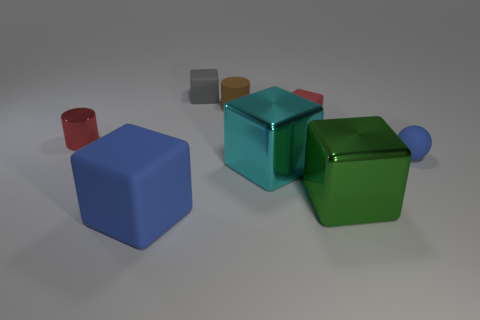Add 2 spheres. How many objects exist? 10 Subtract all yellow blocks. Subtract all yellow spheres. How many blocks are left? 5 Subtract all spheres. How many objects are left? 7 Subtract all brown matte spheres. Subtract all blue rubber cubes. How many objects are left? 7 Add 2 big matte objects. How many big matte objects are left? 3 Add 5 big brown rubber blocks. How many big brown rubber blocks exist? 5 Subtract 1 red cubes. How many objects are left? 7 